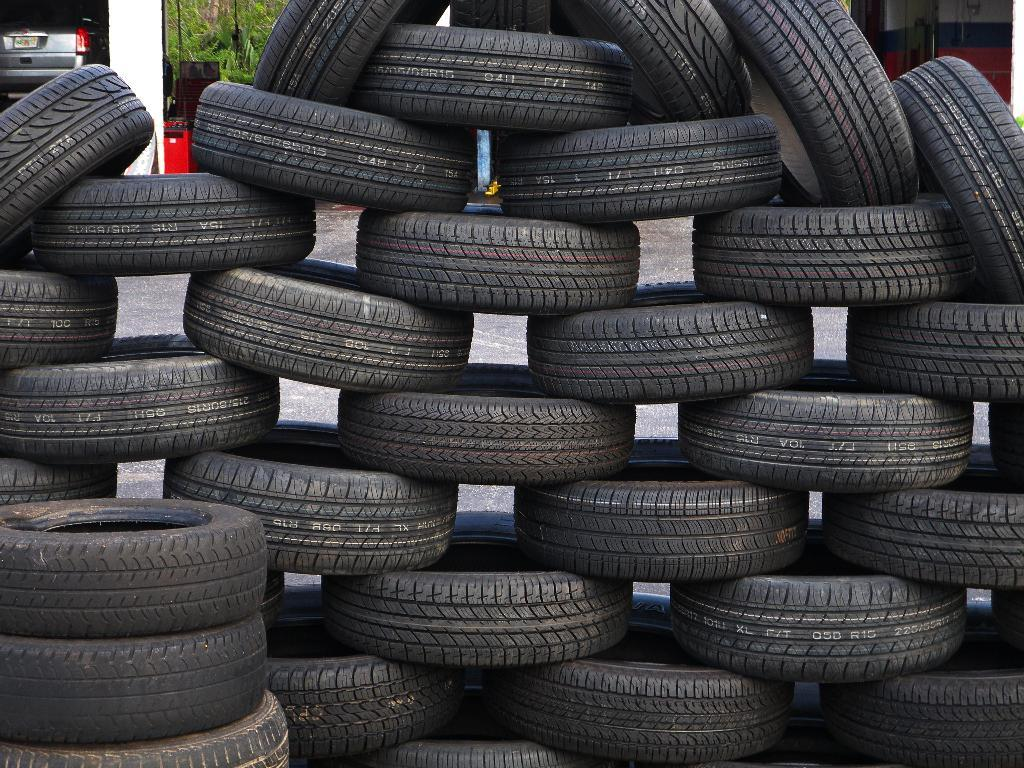What is the color of the tiers in the image? The tiers in the image are black. What can be seen in the background of the image? There is a vehicle and objects in the background of the image, as well as trees. How many giraffes can be seen in the image? There are no giraffes present in the image. What color is the blood on the tiers in the image? There is no blood present in the image. 